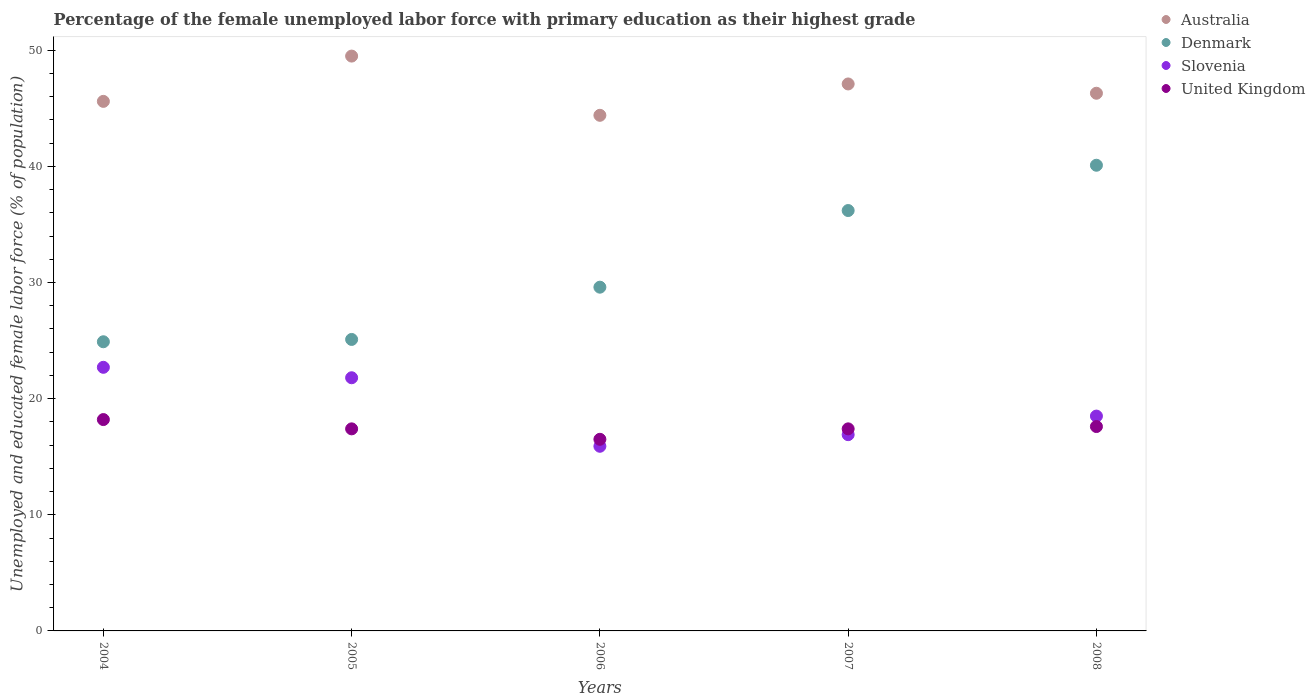What is the percentage of the unemployed female labor force with primary education in Australia in 2008?
Make the answer very short. 46.3. Across all years, what is the maximum percentage of the unemployed female labor force with primary education in Australia?
Your answer should be compact. 49.5. Across all years, what is the minimum percentage of the unemployed female labor force with primary education in United Kingdom?
Ensure brevity in your answer.  16.5. In which year was the percentage of the unemployed female labor force with primary education in Australia maximum?
Offer a very short reply. 2005. What is the total percentage of the unemployed female labor force with primary education in Australia in the graph?
Keep it short and to the point. 232.9. What is the difference between the percentage of the unemployed female labor force with primary education in United Kingdom in 2005 and that in 2006?
Your answer should be very brief. 0.9. What is the difference between the percentage of the unemployed female labor force with primary education in United Kingdom in 2006 and the percentage of the unemployed female labor force with primary education in Denmark in 2004?
Ensure brevity in your answer.  -8.4. What is the average percentage of the unemployed female labor force with primary education in United Kingdom per year?
Offer a terse response. 17.42. In the year 2005, what is the difference between the percentage of the unemployed female labor force with primary education in Australia and percentage of the unemployed female labor force with primary education in Denmark?
Give a very brief answer. 24.4. In how many years, is the percentage of the unemployed female labor force with primary education in Slovenia greater than 14 %?
Your response must be concise. 5. Is the percentage of the unemployed female labor force with primary education in United Kingdom in 2006 less than that in 2008?
Offer a very short reply. Yes. What is the difference between the highest and the second highest percentage of the unemployed female labor force with primary education in United Kingdom?
Ensure brevity in your answer.  0.6. What is the difference between the highest and the lowest percentage of the unemployed female labor force with primary education in Australia?
Keep it short and to the point. 5.1. Is the sum of the percentage of the unemployed female labor force with primary education in Slovenia in 2006 and 2008 greater than the maximum percentage of the unemployed female labor force with primary education in United Kingdom across all years?
Offer a terse response. Yes. How many dotlines are there?
Ensure brevity in your answer.  4. How many years are there in the graph?
Make the answer very short. 5. Are the values on the major ticks of Y-axis written in scientific E-notation?
Provide a succinct answer. No. Does the graph contain grids?
Keep it short and to the point. No. What is the title of the graph?
Your answer should be compact. Percentage of the female unemployed labor force with primary education as their highest grade. Does "Ireland" appear as one of the legend labels in the graph?
Ensure brevity in your answer.  No. What is the label or title of the X-axis?
Make the answer very short. Years. What is the label or title of the Y-axis?
Offer a terse response. Unemployed and educated female labor force (% of population). What is the Unemployed and educated female labor force (% of population) in Australia in 2004?
Ensure brevity in your answer.  45.6. What is the Unemployed and educated female labor force (% of population) of Denmark in 2004?
Your response must be concise. 24.9. What is the Unemployed and educated female labor force (% of population) of Slovenia in 2004?
Make the answer very short. 22.7. What is the Unemployed and educated female labor force (% of population) of United Kingdom in 2004?
Keep it short and to the point. 18.2. What is the Unemployed and educated female labor force (% of population) of Australia in 2005?
Ensure brevity in your answer.  49.5. What is the Unemployed and educated female labor force (% of population) in Denmark in 2005?
Keep it short and to the point. 25.1. What is the Unemployed and educated female labor force (% of population) in Slovenia in 2005?
Your response must be concise. 21.8. What is the Unemployed and educated female labor force (% of population) of United Kingdom in 2005?
Provide a short and direct response. 17.4. What is the Unemployed and educated female labor force (% of population) in Australia in 2006?
Provide a short and direct response. 44.4. What is the Unemployed and educated female labor force (% of population) of Denmark in 2006?
Ensure brevity in your answer.  29.6. What is the Unemployed and educated female labor force (% of population) in Slovenia in 2006?
Ensure brevity in your answer.  15.9. What is the Unemployed and educated female labor force (% of population) in United Kingdom in 2006?
Your response must be concise. 16.5. What is the Unemployed and educated female labor force (% of population) of Australia in 2007?
Provide a short and direct response. 47.1. What is the Unemployed and educated female labor force (% of population) in Denmark in 2007?
Offer a terse response. 36.2. What is the Unemployed and educated female labor force (% of population) of Slovenia in 2007?
Your response must be concise. 16.9. What is the Unemployed and educated female labor force (% of population) in United Kingdom in 2007?
Ensure brevity in your answer.  17.4. What is the Unemployed and educated female labor force (% of population) in Australia in 2008?
Give a very brief answer. 46.3. What is the Unemployed and educated female labor force (% of population) in Denmark in 2008?
Ensure brevity in your answer.  40.1. What is the Unemployed and educated female labor force (% of population) of United Kingdom in 2008?
Your response must be concise. 17.6. Across all years, what is the maximum Unemployed and educated female labor force (% of population) in Australia?
Make the answer very short. 49.5. Across all years, what is the maximum Unemployed and educated female labor force (% of population) in Denmark?
Make the answer very short. 40.1. Across all years, what is the maximum Unemployed and educated female labor force (% of population) of Slovenia?
Your response must be concise. 22.7. Across all years, what is the maximum Unemployed and educated female labor force (% of population) in United Kingdom?
Your response must be concise. 18.2. Across all years, what is the minimum Unemployed and educated female labor force (% of population) in Australia?
Offer a very short reply. 44.4. Across all years, what is the minimum Unemployed and educated female labor force (% of population) of Denmark?
Offer a very short reply. 24.9. Across all years, what is the minimum Unemployed and educated female labor force (% of population) in Slovenia?
Ensure brevity in your answer.  15.9. Across all years, what is the minimum Unemployed and educated female labor force (% of population) of United Kingdom?
Ensure brevity in your answer.  16.5. What is the total Unemployed and educated female labor force (% of population) in Australia in the graph?
Provide a succinct answer. 232.9. What is the total Unemployed and educated female labor force (% of population) in Denmark in the graph?
Provide a succinct answer. 155.9. What is the total Unemployed and educated female labor force (% of population) of Slovenia in the graph?
Provide a short and direct response. 95.8. What is the total Unemployed and educated female labor force (% of population) in United Kingdom in the graph?
Offer a very short reply. 87.1. What is the difference between the Unemployed and educated female labor force (% of population) in Denmark in 2004 and that in 2005?
Make the answer very short. -0.2. What is the difference between the Unemployed and educated female labor force (% of population) in United Kingdom in 2004 and that in 2005?
Your response must be concise. 0.8. What is the difference between the Unemployed and educated female labor force (% of population) in Australia in 2004 and that in 2006?
Your response must be concise. 1.2. What is the difference between the Unemployed and educated female labor force (% of population) of United Kingdom in 2004 and that in 2006?
Ensure brevity in your answer.  1.7. What is the difference between the Unemployed and educated female labor force (% of population) in Australia in 2004 and that in 2007?
Provide a short and direct response. -1.5. What is the difference between the Unemployed and educated female labor force (% of population) of Denmark in 2004 and that in 2008?
Provide a short and direct response. -15.2. What is the difference between the Unemployed and educated female labor force (% of population) in Denmark in 2005 and that in 2006?
Your response must be concise. -4.5. What is the difference between the Unemployed and educated female labor force (% of population) of United Kingdom in 2005 and that in 2006?
Ensure brevity in your answer.  0.9. What is the difference between the Unemployed and educated female labor force (% of population) of Australia in 2005 and that in 2008?
Give a very brief answer. 3.2. What is the difference between the Unemployed and educated female labor force (% of population) of Denmark in 2005 and that in 2008?
Provide a short and direct response. -15. What is the difference between the Unemployed and educated female labor force (% of population) in Slovenia in 2005 and that in 2008?
Make the answer very short. 3.3. What is the difference between the Unemployed and educated female labor force (% of population) in Denmark in 2006 and that in 2007?
Your response must be concise. -6.6. What is the difference between the Unemployed and educated female labor force (% of population) of Denmark in 2006 and that in 2008?
Provide a short and direct response. -10.5. What is the difference between the Unemployed and educated female labor force (% of population) of Slovenia in 2006 and that in 2008?
Your answer should be compact. -2.6. What is the difference between the Unemployed and educated female labor force (% of population) of Australia in 2004 and the Unemployed and educated female labor force (% of population) of Denmark in 2005?
Provide a short and direct response. 20.5. What is the difference between the Unemployed and educated female labor force (% of population) in Australia in 2004 and the Unemployed and educated female labor force (% of population) in Slovenia in 2005?
Provide a short and direct response. 23.8. What is the difference between the Unemployed and educated female labor force (% of population) of Australia in 2004 and the Unemployed and educated female labor force (% of population) of United Kingdom in 2005?
Keep it short and to the point. 28.2. What is the difference between the Unemployed and educated female labor force (% of population) in Australia in 2004 and the Unemployed and educated female labor force (% of population) in Slovenia in 2006?
Offer a very short reply. 29.7. What is the difference between the Unemployed and educated female labor force (% of population) in Australia in 2004 and the Unemployed and educated female labor force (% of population) in United Kingdom in 2006?
Give a very brief answer. 29.1. What is the difference between the Unemployed and educated female labor force (% of population) of Denmark in 2004 and the Unemployed and educated female labor force (% of population) of Slovenia in 2006?
Provide a succinct answer. 9. What is the difference between the Unemployed and educated female labor force (% of population) in Denmark in 2004 and the Unemployed and educated female labor force (% of population) in United Kingdom in 2006?
Your response must be concise. 8.4. What is the difference between the Unemployed and educated female labor force (% of population) in Australia in 2004 and the Unemployed and educated female labor force (% of population) in Denmark in 2007?
Keep it short and to the point. 9.4. What is the difference between the Unemployed and educated female labor force (% of population) of Australia in 2004 and the Unemployed and educated female labor force (% of population) of Slovenia in 2007?
Offer a very short reply. 28.7. What is the difference between the Unemployed and educated female labor force (% of population) of Australia in 2004 and the Unemployed and educated female labor force (% of population) of United Kingdom in 2007?
Keep it short and to the point. 28.2. What is the difference between the Unemployed and educated female labor force (% of population) of Denmark in 2004 and the Unemployed and educated female labor force (% of population) of Slovenia in 2007?
Your response must be concise. 8. What is the difference between the Unemployed and educated female labor force (% of population) of Denmark in 2004 and the Unemployed and educated female labor force (% of population) of United Kingdom in 2007?
Your response must be concise. 7.5. What is the difference between the Unemployed and educated female labor force (% of population) in Australia in 2004 and the Unemployed and educated female labor force (% of population) in Slovenia in 2008?
Provide a succinct answer. 27.1. What is the difference between the Unemployed and educated female labor force (% of population) of Australia in 2004 and the Unemployed and educated female labor force (% of population) of United Kingdom in 2008?
Ensure brevity in your answer.  28. What is the difference between the Unemployed and educated female labor force (% of population) in Denmark in 2004 and the Unemployed and educated female labor force (% of population) in Slovenia in 2008?
Ensure brevity in your answer.  6.4. What is the difference between the Unemployed and educated female labor force (% of population) in Denmark in 2004 and the Unemployed and educated female labor force (% of population) in United Kingdom in 2008?
Your answer should be compact. 7.3. What is the difference between the Unemployed and educated female labor force (% of population) in Slovenia in 2004 and the Unemployed and educated female labor force (% of population) in United Kingdom in 2008?
Give a very brief answer. 5.1. What is the difference between the Unemployed and educated female labor force (% of population) in Australia in 2005 and the Unemployed and educated female labor force (% of population) in Denmark in 2006?
Offer a terse response. 19.9. What is the difference between the Unemployed and educated female labor force (% of population) of Australia in 2005 and the Unemployed and educated female labor force (% of population) of Slovenia in 2006?
Your answer should be compact. 33.6. What is the difference between the Unemployed and educated female labor force (% of population) in Denmark in 2005 and the Unemployed and educated female labor force (% of population) in Slovenia in 2006?
Offer a very short reply. 9.2. What is the difference between the Unemployed and educated female labor force (% of population) in Slovenia in 2005 and the Unemployed and educated female labor force (% of population) in United Kingdom in 2006?
Offer a very short reply. 5.3. What is the difference between the Unemployed and educated female labor force (% of population) in Australia in 2005 and the Unemployed and educated female labor force (% of population) in Denmark in 2007?
Your response must be concise. 13.3. What is the difference between the Unemployed and educated female labor force (% of population) of Australia in 2005 and the Unemployed and educated female labor force (% of population) of Slovenia in 2007?
Provide a succinct answer. 32.6. What is the difference between the Unemployed and educated female labor force (% of population) in Australia in 2005 and the Unemployed and educated female labor force (% of population) in United Kingdom in 2007?
Make the answer very short. 32.1. What is the difference between the Unemployed and educated female labor force (% of population) of Slovenia in 2005 and the Unemployed and educated female labor force (% of population) of United Kingdom in 2007?
Provide a succinct answer. 4.4. What is the difference between the Unemployed and educated female labor force (% of population) of Australia in 2005 and the Unemployed and educated female labor force (% of population) of Slovenia in 2008?
Ensure brevity in your answer.  31. What is the difference between the Unemployed and educated female labor force (% of population) in Australia in 2005 and the Unemployed and educated female labor force (% of population) in United Kingdom in 2008?
Your answer should be very brief. 31.9. What is the difference between the Unemployed and educated female labor force (% of population) in Denmark in 2005 and the Unemployed and educated female labor force (% of population) in Slovenia in 2008?
Make the answer very short. 6.6. What is the difference between the Unemployed and educated female labor force (% of population) of Denmark in 2005 and the Unemployed and educated female labor force (% of population) of United Kingdom in 2008?
Ensure brevity in your answer.  7.5. What is the difference between the Unemployed and educated female labor force (% of population) in Slovenia in 2005 and the Unemployed and educated female labor force (% of population) in United Kingdom in 2008?
Your answer should be very brief. 4.2. What is the difference between the Unemployed and educated female labor force (% of population) of Australia in 2006 and the Unemployed and educated female labor force (% of population) of Slovenia in 2007?
Ensure brevity in your answer.  27.5. What is the difference between the Unemployed and educated female labor force (% of population) of Denmark in 2006 and the Unemployed and educated female labor force (% of population) of Slovenia in 2007?
Your answer should be compact. 12.7. What is the difference between the Unemployed and educated female labor force (% of population) of Australia in 2006 and the Unemployed and educated female labor force (% of population) of Slovenia in 2008?
Give a very brief answer. 25.9. What is the difference between the Unemployed and educated female labor force (% of population) of Australia in 2006 and the Unemployed and educated female labor force (% of population) of United Kingdom in 2008?
Offer a terse response. 26.8. What is the difference between the Unemployed and educated female labor force (% of population) of Denmark in 2006 and the Unemployed and educated female labor force (% of population) of United Kingdom in 2008?
Your answer should be compact. 12. What is the difference between the Unemployed and educated female labor force (% of population) of Australia in 2007 and the Unemployed and educated female labor force (% of population) of Denmark in 2008?
Provide a short and direct response. 7. What is the difference between the Unemployed and educated female labor force (% of population) in Australia in 2007 and the Unemployed and educated female labor force (% of population) in Slovenia in 2008?
Offer a terse response. 28.6. What is the difference between the Unemployed and educated female labor force (% of population) of Australia in 2007 and the Unemployed and educated female labor force (% of population) of United Kingdom in 2008?
Your response must be concise. 29.5. What is the difference between the Unemployed and educated female labor force (% of population) in Denmark in 2007 and the Unemployed and educated female labor force (% of population) in United Kingdom in 2008?
Offer a very short reply. 18.6. What is the difference between the Unemployed and educated female labor force (% of population) in Slovenia in 2007 and the Unemployed and educated female labor force (% of population) in United Kingdom in 2008?
Make the answer very short. -0.7. What is the average Unemployed and educated female labor force (% of population) in Australia per year?
Provide a succinct answer. 46.58. What is the average Unemployed and educated female labor force (% of population) of Denmark per year?
Make the answer very short. 31.18. What is the average Unemployed and educated female labor force (% of population) of Slovenia per year?
Provide a short and direct response. 19.16. What is the average Unemployed and educated female labor force (% of population) in United Kingdom per year?
Offer a very short reply. 17.42. In the year 2004, what is the difference between the Unemployed and educated female labor force (% of population) of Australia and Unemployed and educated female labor force (% of population) of Denmark?
Make the answer very short. 20.7. In the year 2004, what is the difference between the Unemployed and educated female labor force (% of population) of Australia and Unemployed and educated female labor force (% of population) of Slovenia?
Make the answer very short. 22.9. In the year 2004, what is the difference between the Unemployed and educated female labor force (% of population) in Australia and Unemployed and educated female labor force (% of population) in United Kingdom?
Provide a succinct answer. 27.4. In the year 2004, what is the difference between the Unemployed and educated female labor force (% of population) in Denmark and Unemployed and educated female labor force (% of population) in Slovenia?
Make the answer very short. 2.2. In the year 2004, what is the difference between the Unemployed and educated female labor force (% of population) in Slovenia and Unemployed and educated female labor force (% of population) in United Kingdom?
Ensure brevity in your answer.  4.5. In the year 2005, what is the difference between the Unemployed and educated female labor force (% of population) in Australia and Unemployed and educated female labor force (% of population) in Denmark?
Your response must be concise. 24.4. In the year 2005, what is the difference between the Unemployed and educated female labor force (% of population) of Australia and Unemployed and educated female labor force (% of population) of Slovenia?
Your answer should be compact. 27.7. In the year 2005, what is the difference between the Unemployed and educated female labor force (% of population) of Australia and Unemployed and educated female labor force (% of population) of United Kingdom?
Make the answer very short. 32.1. In the year 2005, what is the difference between the Unemployed and educated female labor force (% of population) of Denmark and Unemployed and educated female labor force (% of population) of United Kingdom?
Give a very brief answer. 7.7. In the year 2006, what is the difference between the Unemployed and educated female labor force (% of population) in Australia and Unemployed and educated female labor force (% of population) in United Kingdom?
Give a very brief answer. 27.9. In the year 2006, what is the difference between the Unemployed and educated female labor force (% of population) of Denmark and Unemployed and educated female labor force (% of population) of United Kingdom?
Ensure brevity in your answer.  13.1. In the year 2007, what is the difference between the Unemployed and educated female labor force (% of population) of Australia and Unemployed and educated female labor force (% of population) of Denmark?
Ensure brevity in your answer.  10.9. In the year 2007, what is the difference between the Unemployed and educated female labor force (% of population) in Australia and Unemployed and educated female labor force (% of population) in Slovenia?
Keep it short and to the point. 30.2. In the year 2007, what is the difference between the Unemployed and educated female labor force (% of population) of Australia and Unemployed and educated female labor force (% of population) of United Kingdom?
Give a very brief answer. 29.7. In the year 2007, what is the difference between the Unemployed and educated female labor force (% of population) in Denmark and Unemployed and educated female labor force (% of population) in Slovenia?
Offer a very short reply. 19.3. In the year 2007, what is the difference between the Unemployed and educated female labor force (% of population) in Slovenia and Unemployed and educated female labor force (% of population) in United Kingdom?
Give a very brief answer. -0.5. In the year 2008, what is the difference between the Unemployed and educated female labor force (% of population) in Australia and Unemployed and educated female labor force (% of population) in Denmark?
Make the answer very short. 6.2. In the year 2008, what is the difference between the Unemployed and educated female labor force (% of population) of Australia and Unemployed and educated female labor force (% of population) of Slovenia?
Make the answer very short. 27.8. In the year 2008, what is the difference between the Unemployed and educated female labor force (% of population) of Australia and Unemployed and educated female labor force (% of population) of United Kingdom?
Provide a short and direct response. 28.7. In the year 2008, what is the difference between the Unemployed and educated female labor force (% of population) of Denmark and Unemployed and educated female labor force (% of population) of Slovenia?
Make the answer very short. 21.6. What is the ratio of the Unemployed and educated female labor force (% of population) in Australia in 2004 to that in 2005?
Provide a short and direct response. 0.92. What is the ratio of the Unemployed and educated female labor force (% of population) in Slovenia in 2004 to that in 2005?
Ensure brevity in your answer.  1.04. What is the ratio of the Unemployed and educated female labor force (% of population) of United Kingdom in 2004 to that in 2005?
Offer a very short reply. 1.05. What is the ratio of the Unemployed and educated female labor force (% of population) in Denmark in 2004 to that in 2006?
Give a very brief answer. 0.84. What is the ratio of the Unemployed and educated female labor force (% of population) of Slovenia in 2004 to that in 2006?
Provide a succinct answer. 1.43. What is the ratio of the Unemployed and educated female labor force (% of population) in United Kingdom in 2004 to that in 2006?
Offer a very short reply. 1.1. What is the ratio of the Unemployed and educated female labor force (% of population) of Australia in 2004 to that in 2007?
Your answer should be compact. 0.97. What is the ratio of the Unemployed and educated female labor force (% of population) in Denmark in 2004 to that in 2007?
Your answer should be very brief. 0.69. What is the ratio of the Unemployed and educated female labor force (% of population) of Slovenia in 2004 to that in 2007?
Offer a terse response. 1.34. What is the ratio of the Unemployed and educated female labor force (% of population) of United Kingdom in 2004 to that in 2007?
Provide a short and direct response. 1.05. What is the ratio of the Unemployed and educated female labor force (% of population) of Australia in 2004 to that in 2008?
Keep it short and to the point. 0.98. What is the ratio of the Unemployed and educated female labor force (% of population) in Denmark in 2004 to that in 2008?
Make the answer very short. 0.62. What is the ratio of the Unemployed and educated female labor force (% of population) in Slovenia in 2004 to that in 2008?
Your answer should be compact. 1.23. What is the ratio of the Unemployed and educated female labor force (% of population) in United Kingdom in 2004 to that in 2008?
Provide a succinct answer. 1.03. What is the ratio of the Unemployed and educated female labor force (% of population) in Australia in 2005 to that in 2006?
Ensure brevity in your answer.  1.11. What is the ratio of the Unemployed and educated female labor force (% of population) of Denmark in 2005 to that in 2006?
Your answer should be compact. 0.85. What is the ratio of the Unemployed and educated female labor force (% of population) in Slovenia in 2005 to that in 2006?
Make the answer very short. 1.37. What is the ratio of the Unemployed and educated female labor force (% of population) in United Kingdom in 2005 to that in 2006?
Give a very brief answer. 1.05. What is the ratio of the Unemployed and educated female labor force (% of population) of Australia in 2005 to that in 2007?
Your answer should be very brief. 1.05. What is the ratio of the Unemployed and educated female labor force (% of population) in Denmark in 2005 to that in 2007?
Your answer should be compact. 0.69. What is the ratio of the Unemployed and educated female labor force (% of population) of Slovenia in 2005 to that in 2007?
Your answer should be compact. 1.29. What is the ratio of the Unemployed and educated female labor force (% of population) of United Kingdom in 2005 to that in 2007?
Offer a very short reply. 1. What is the ratio of the Unemployed and educated female labor force (% of population) of Australia in 2005 to that in 2008?
Your answer should be compact. 1.07. What is the ratio of the Unemployed and educated female labor force (% of population) in Denmark in 2005 to that in 2008?
Make the answer very short. 0.63. What is the ratio of the Unemployed and educated female labor force (% of population) of Slovenia in 2005 to that in 2008?
Offer a terse response. 1.18. What is the ratio of the Unemployed and educated female labor force (% of population) in United Kingdom in 2005 to that in 2008?
Offer a terse response. 0.99. What is the ratio of the Unemployed and educated female labor force (% of population) in Australia in 2006 to that in 2007?
Your response must be concise. 0.94. What is the ratio of the Unemployed and educated female labor force (% of population) in Denmark in 2006 to that in 2007?
Your answer should be compact. 0.82. What is the ratio of the Unemployed and educated female labor force (% of population) of Slovenia in 2006 to that in 2007?
Offer a terse response. 0.94. What is the ratio of the Unemployed and educated female labor force (% of population) of United Kingdom in 2006 to that in 2007?
Give a very brief answer. 0.95. What is the ratio of the Unemployed and educated female labor force (% of population) in Australia in 2006 to that in 2008?
Provide a short and direct response. 0.96. What is the ratio of the Unemployed and educated female labor force (% of population) of Denmark in 2006 to that in 2008?
Offer a terse response. 0.74. What is the ratio of the Unemployed and educated female labor force (% of population) of Slovenia in 2006 to that in 2008?
Offer a very short reply. 0.86. What is the ratio of the Unemployed and educated female labor force (% of population) in United Kingdom in 2006 to that in 2008?
Offer a terse response. 0.94. What is the ratio of the Unemployed and educated female labor force (% of population) in Australia in 2007 to that in 2008?
Your answer should be compact. 1.02. What is the ratio of the Unemployed and educated female labor force (% of population) of Denmark in 2007 to that in 2008?
Provide a succinct answer. 0.9. What is the ratio of the Unemployed and educated female labor force (% of population) in Slovenia in 2007 to that in 2008?
Your answer should be very brief. 0.91. What is the difference between the highest and the second highest Unemployed and educated female labor force (% of population) in Denmark?
Provide a succinct answer. 3.9. What is the difference between the highest and the second highest Unemployed and educated female labor force (% of population) in United Kingdom?
Ensure brevity in your answer.  0.6. What is the difference between the highest and the lowest Unemployed and educated female labor force (% of population) in Australia?
Offer a very short reply. 5.1. What is the difference between the highest and the lowest Unemployed and educated female labor force (% of population) in Slovenia?
Provide a succinct answer. 6.8. 